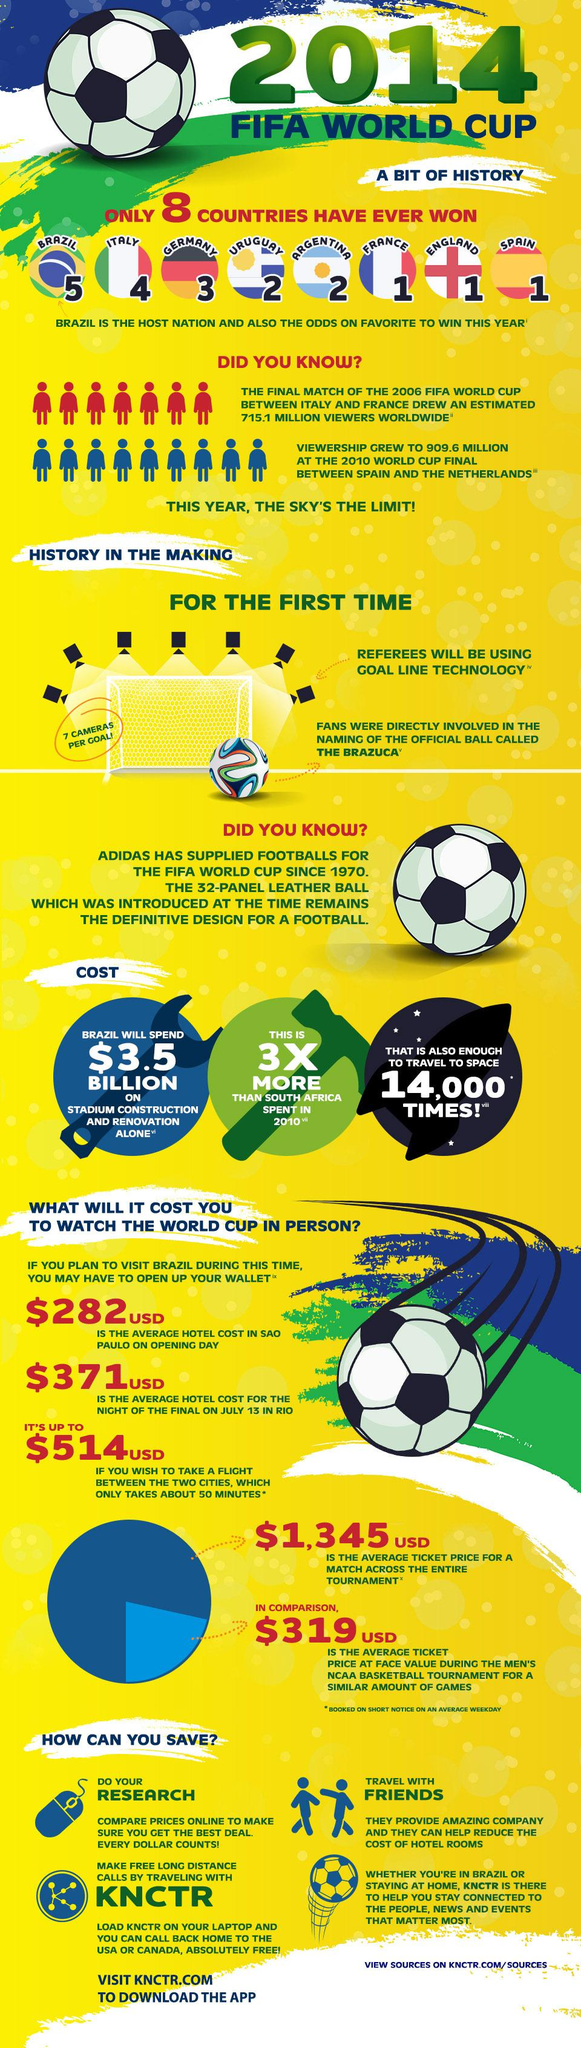Mention a couple of crucial points in this snapshot. The cost for traveling to space 14,000 times is approximately $3.5 billion. From 2006 to 2010, the number of viewers increased by approximately 194.5 million. The total average hotel cost for the opening day in Sao Paulo and the night of the final in Rio is estimated to be $653 France, England, and Spain have each won the FIFA World Cup once. Uruguay and Argentina are countries that have won the FIFA World Cup two times. 